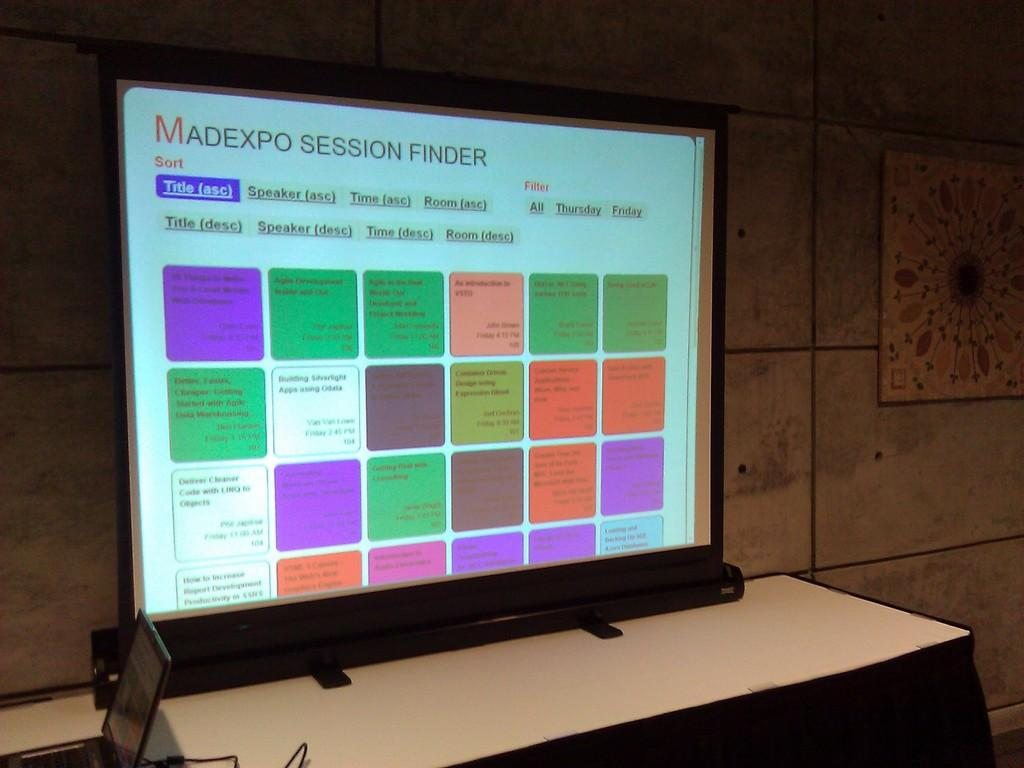<image>
Offer a succinct explanation of the picture presented. A television screen is displaying the Madexpo Session Finder. 